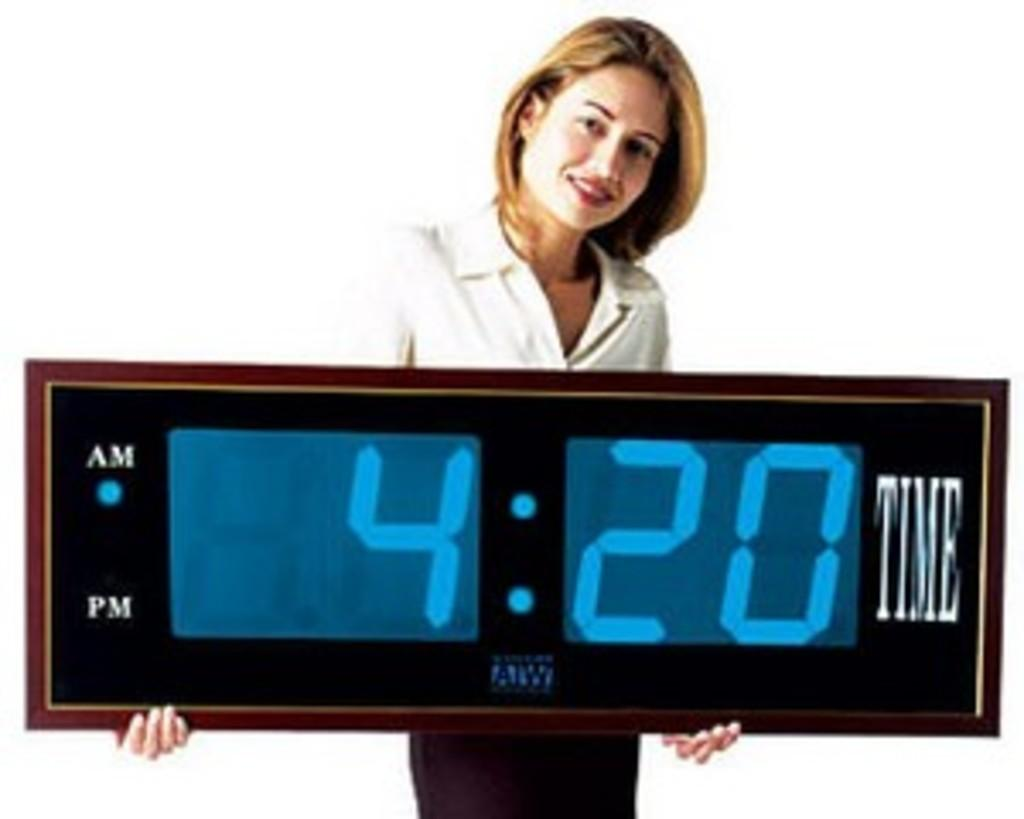<image>
Share a concise interpretation of the image provided. A woman is holding a huge clock with the time 4:20am. 